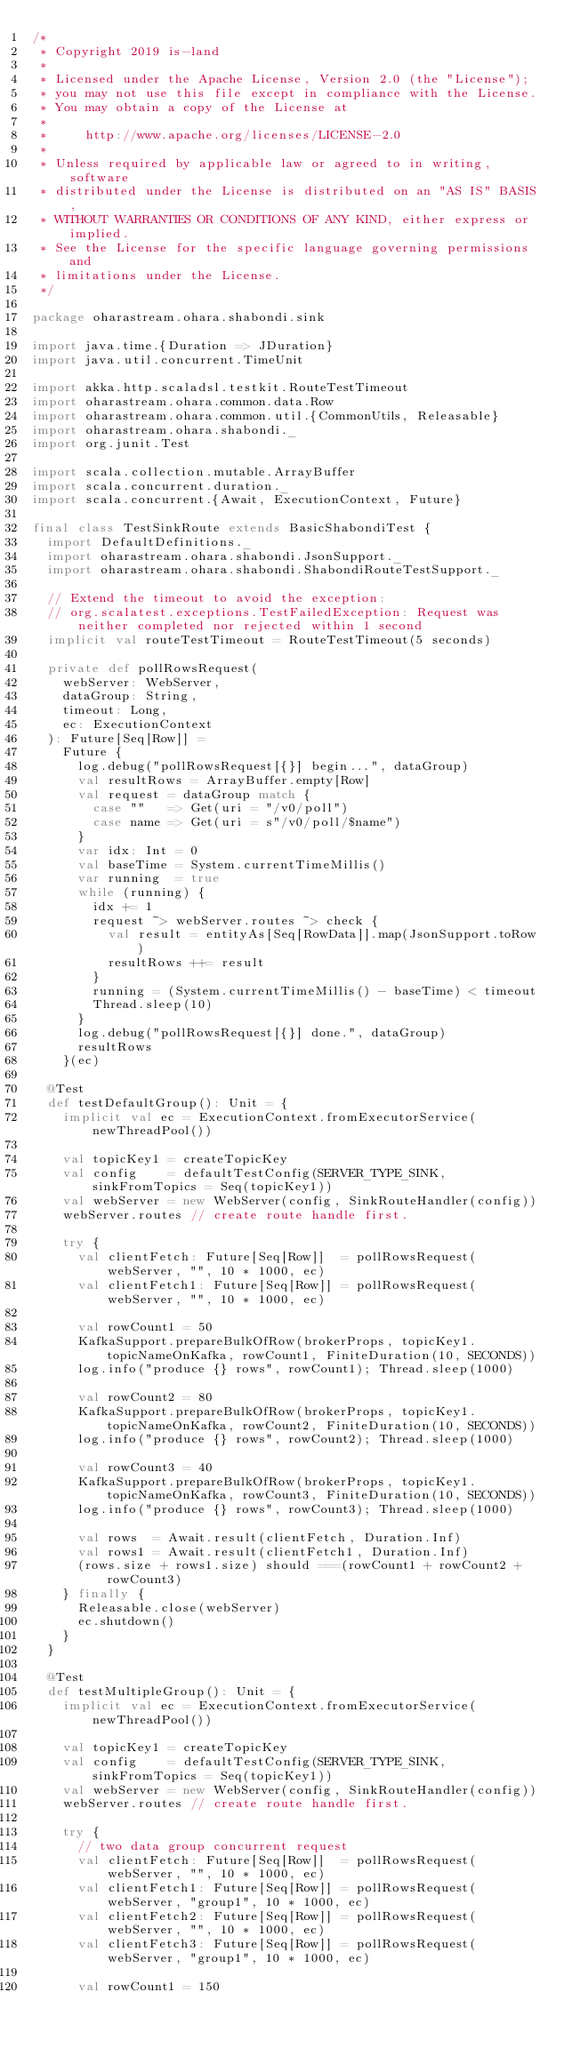Convert code to text. <code><loc_0><loc_0><loc_500><loc_500><_Scala_>/*
 * Copyright 2019 is-land
 *
 * Licensed under the Apache License, Version 2.0 (the "License");
 * you may not use this file except in compliance with the License.
 * You may obtain a copy of the License at
 *
 *     http://www.apache.org/licenses/LICENSE-2.0
 *
 * Unless required by applicable law or agreed to in writing, software
 * distributed under the License is distributed on an "AS IS" BASIS,
 * WITHOUT WARRANTIES OR CONDITIONS OF ANY KIND, either express or implied.
 * See the License for the specific language governing permissions and
 * limitations under the License.
 */

package oharastream.ohara.shabondi.sink

import java.time.{Duration => JDuration}
import java.util.concurrent.TimeUnit

import akka.http.scaladsl.testkit.RouteTestTimeout
import oharastream.ohara.common.data.Row
import oharastream.ohara.common.util.{CommonUtils, Releasable}
import oharastream.ohara.shabondi._
import org.junit.Test

import scala.collection.mutable.ArrayBuffer
import scala.concurrent.duration._
import scala.concurrent.{Await, ExecutionContext, Future}

final class TestSinkRoute extends BasicShabondiTest {
  import DefaultDefinitions._
  import oharastream.ohara.shabondi.JsonSupport._
  import oharastream.ohara.shabondi.ShabondiRouteTestSupport._

  // Extend the timeout to avoid the exception:
  // org.scalatest.exceptions.TestFailedException: Request was neither completed nor rejected within 1 second
  implicit val routeTestTimeout = RouteTestTimeout(5 seconds)

  private def pollRowsRequest(
    webServer: WebServer,
    dataGroup: String,
    timeout: Long,
    ec: ExecutionContext
  ): Future[Seq[Row]] =
    Future {
      log.debug("pollRowsRequest[{}] begin...", dataGroup)
      val resultRows = ArrayBuffer.empty[Row]
      val request = dataGroup match {
        case ""   => Get(uri = "/v0/poll")
        case name => Get(uri = s"/v0/poll/$name")
      }
      var idx: Int = 0
      val baseTime = System.currentTimeMillis()
      var running  = true
      while (running) {
        idx += 1
        request ~> webServer.routes ~> check {
          val result = entityAs[Seq[RowData]].map(JsonSupport.toRow)
          resultRows ++= result
        }
        running = (System.currentTimeMillis() - baseTime) < timeout
        Thread.sleep(10)
      }
      log.debug("pollRowsRequest[{}] done.", dataGroup)
      resultRows
    }(ec)

  @Test
  def testDefaultGroup(): Unit = {
    implicit val ec = ExecutionContext.fromExecutorService(newThreadPool())

    val topicKey1 = createTopicKey
    val config    = defaultTestConfig(SERVER_TYPE_SINK, sinkFromTopics = Seq(topicKey1))
    val webServer = new WebServer(config, SinkRouteHandler(config))
    webServer.routes // create route handle first.

    try {
      val clientFetch: Future[Seq[Row]]  = pollRowsRequest(webServer, "", 10 * 1000, ec)
      val clientFetch1: Future[Seq[Row]] = pollRowsRequest(webServer, "", 10 * 1000, ec)

      val rowCount1 = 50
      KafkaSupport.prepareBulkOfRow(brokerProps, topicKey1.topicNameOnKafka, rowCount1, FiniteDuration(10, SECONDS))
      log.info("produce {} rows", rowCount1); Thread.sleep(1000)

      val rowCount2 = 80
      KafkaSupport.prepareBulkOfRow(brokerProps, topicKey1.topicNameOnKafka, rowCount2, FiniteDuration(10, SECONDS))
      log.info("produce {} rows", rowCount2); Thread.sleep(1000)

      val rowCount3 = 40
      KafkaSupport.prepareBulkOfRow(brokerProps, topicKey1.topicNameOnKafka, rowCount3, FiniteDuration(10, SECONDS))
      log.info("produce {} rows", rowCount3); Thread.sleep(1000)

      val rows  = Await.result(clientFetch, Duration.Inf)
      val rows1 = Await.result(clientFetch1, Duration.Inf)
      (rows.size + rows1.size) should ===(rowCount1 + rowCount2 + rowCount3)
    } finally {
      Releasable.close(webServer)
      ec.shutdown()
    }
  }

  @Test
  def testMultipleGroup(): Unit = {
    implicit val ec = ExecutionContext.fromExecutorService(newThreadPool())

    val topicKey1 = createTopicKey
    val config    = defaultTestConfig(SERVER_TYPE_SINK, sinkFromTopics = Seq(topicKey1))
    val webServer = new WebServer(config, SinkRouteHandler(config))
    webServer.routes // create route handle first.

    try {
      // two data group concurrent request
      val clientFetch: Future[Seq[Row]]  = pollRowsRequest(webServer, "", 10 * 1000, ec)
      val clientFetch1: Future[Seq[Row]] = pollRowsRequest(webServer, "group1", 10 * 1000, ec)
      val clientFetch2: Future[Seq[Row]] = pollRowsRequest(webServer, "", 10 * 1000, ec)
      val clientFetch3: Future[Seq[Row]] = pollRowsRequest(webServer, "group1", 10 * 1000, ec)

      val rowCount1 = 150</code> 